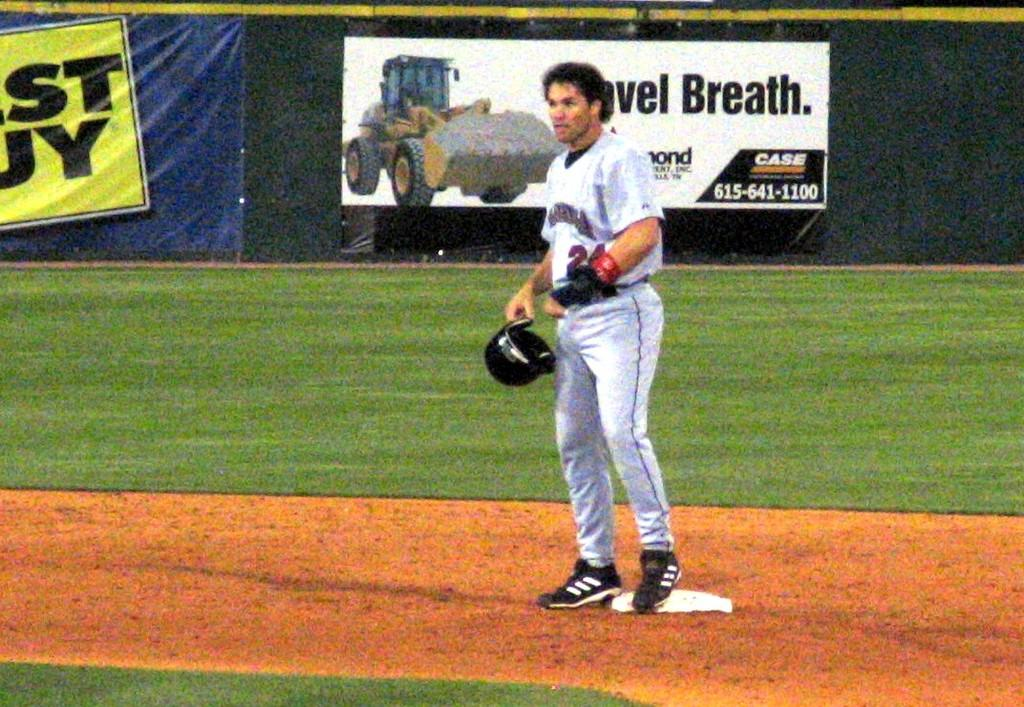<image>
Share a concise interpretation of the image provided. Number 24 stands at a base during a baseball game looking intently at something. 